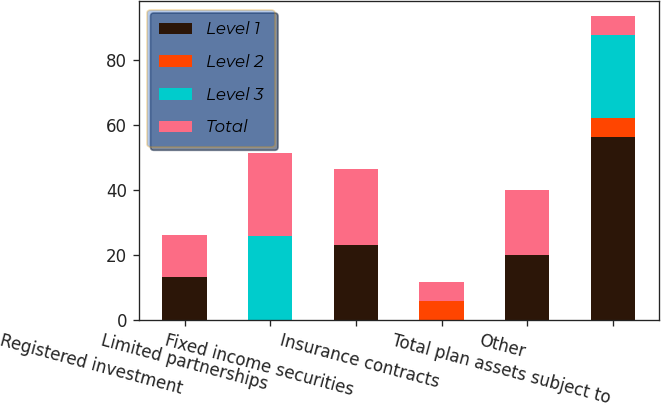Convert chart to OTSL. <chart><loc_0><loc_0><loc_500><loc_500><stacked_bar_chart><ecel><fcel>Registered investment<fcel>Limited partnerships<fcel>Fixed income securities<fcel>Insurance contracts<fcel>Other<fcel>Total plan assets subject to<nl><fcel>Level 1<fcel>13<fcel>0<fcel>23.1<fcel>0<fcel>20<fcel>56.1<nl><fcel>Level 2<fcel>0<fcel>0<fcel>0<fcel>5.8<fcel>0<fcel>5.8<nl><fcel>Level 3<fcel>0<fcel>25.6<fcel>0<fcel>0<fcel>0<fcel>25.6<nl><fcel>Total<fcel>13<fcel>25.6<fcel>23.1<fcel>5.8<fcel>20<fcel>5.8<nl></chart> 